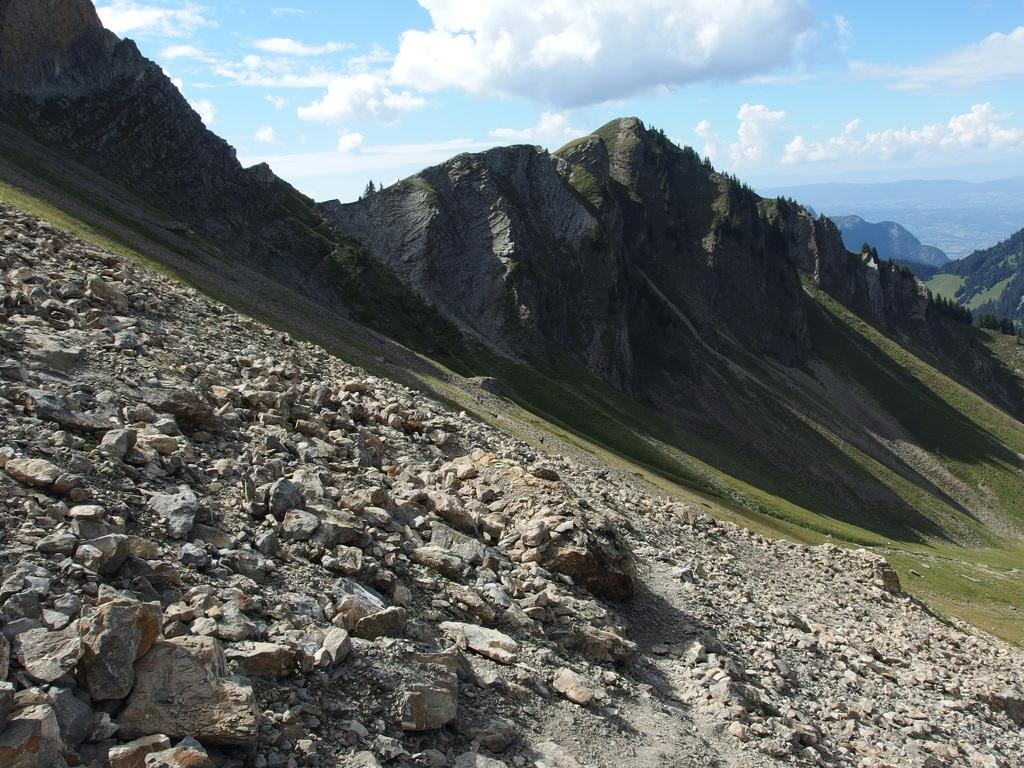What is on the ground in the image? There are stones on the ground in the image. What can be seen in the distance in the image? There are hills visible in the background of the image. What type of vegetation covers the ground in the image? The ground is covered with grass. What is the condition of the sky in the image? The sky is cloudy in the image. What type of popcorn is being held by the grandfather in the image? There is no grandfather or popcorn present in the image. How many fingers does the person holding the popcorn have in the image? There is no person holding popcorn in the image, so it's not possible to determine the number of fingers they might have. 